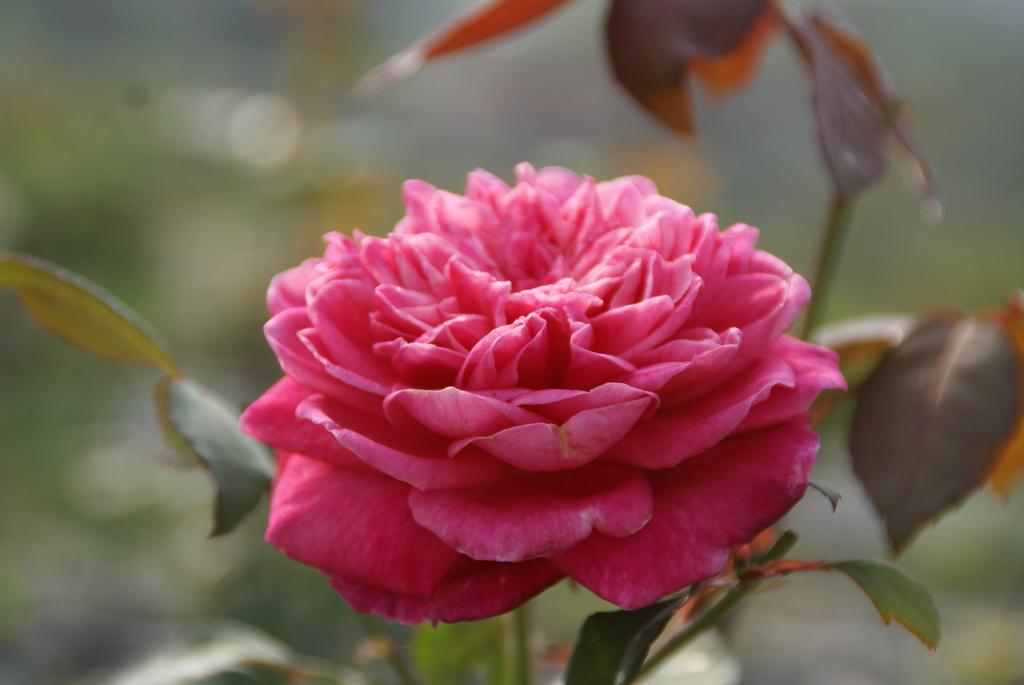What type of plant is in the image? There is a pink flower plant in the image. Can you describe the background of the image? The background of the image is blurry. Are there any games being played in the image? There is no indication of a game being played in the image, as it features a pink flower plant with a blurry background. 